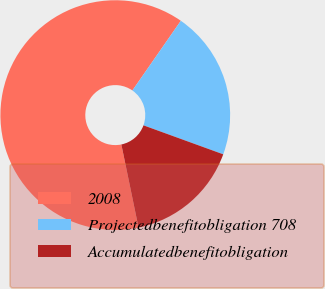Convert chart to OTSL. <chart><loc_0><loc_0><loc_500><loc_500><pie_chart><fcel>2008<fcel>Projectedbenefitobligation 708<fcel>Accumulatedbenefitobligation<nl><fcel>62.92%<fcel>20.88%<fcel>16.21%<nl></chart> 